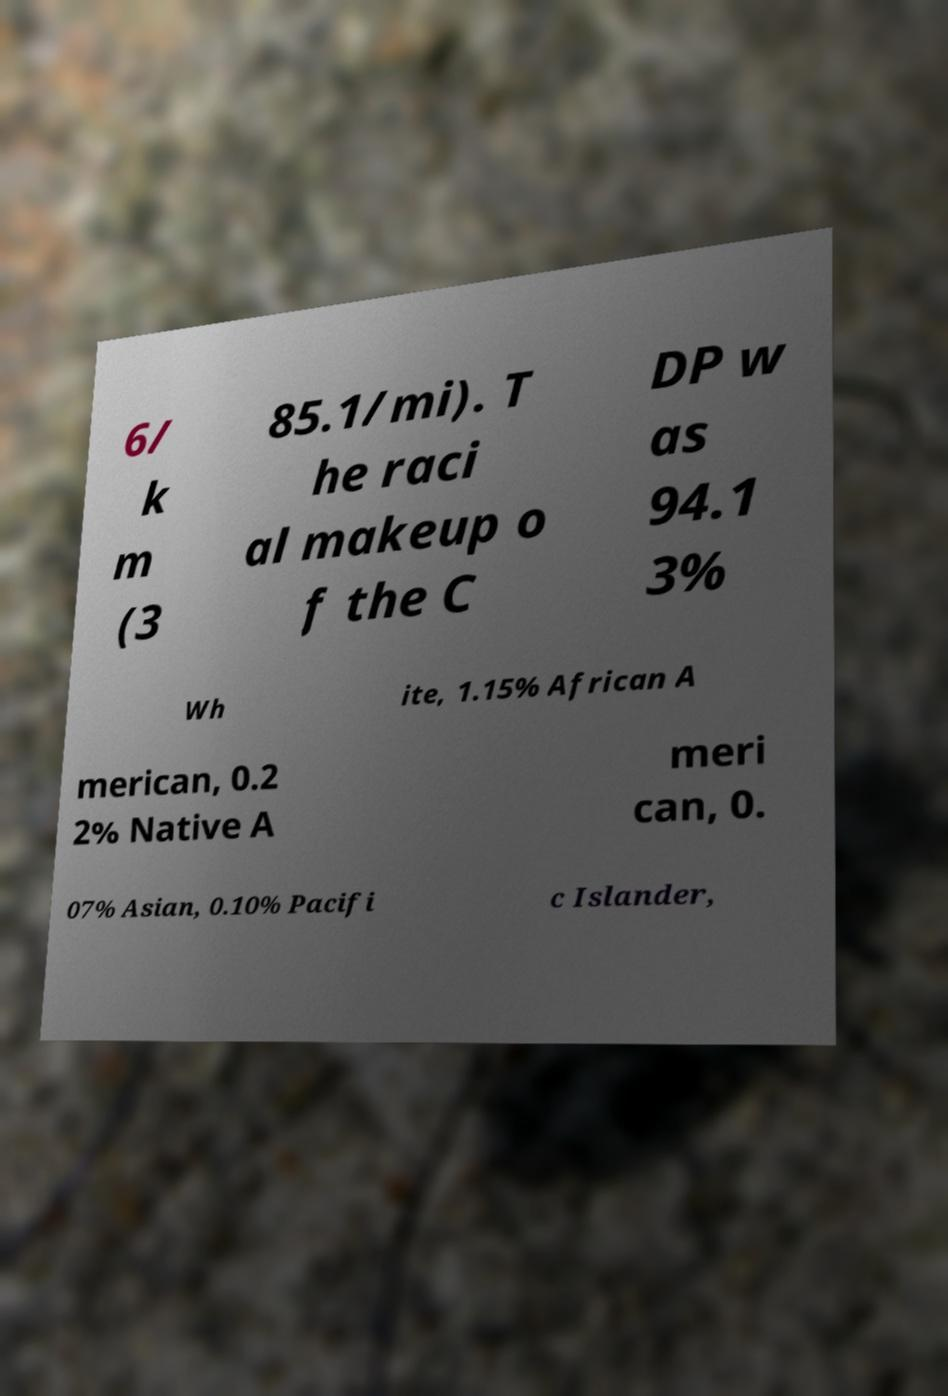I need the written content from this picture converted into text. Can you do that? 6/ k m (3 85.1/mi). T he raci al makeup o f the C DP w as 94.1 3% Wh ite, 1.15% African A merican, 0.2 2% Native A meri can, 0. 07% Asian, 0.10% Pacifi c Islander, 